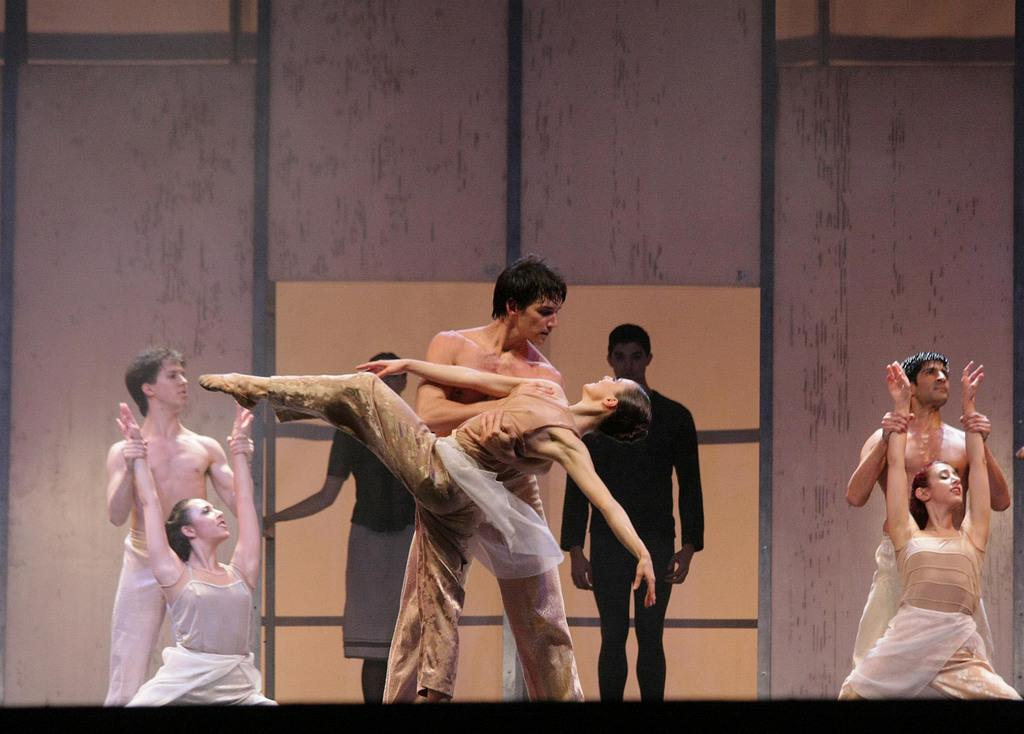What are the people in the image doing? The people in the image are performing dance. Can you describe the background of the image? Two people are standing in the background, and there is a wall visible in the image. What type of thrill can be seen in the image? There is no specific thrill depicted in the image; it features people performing dance. Can you see a rake being used in the image? There is no rake present in the image. 